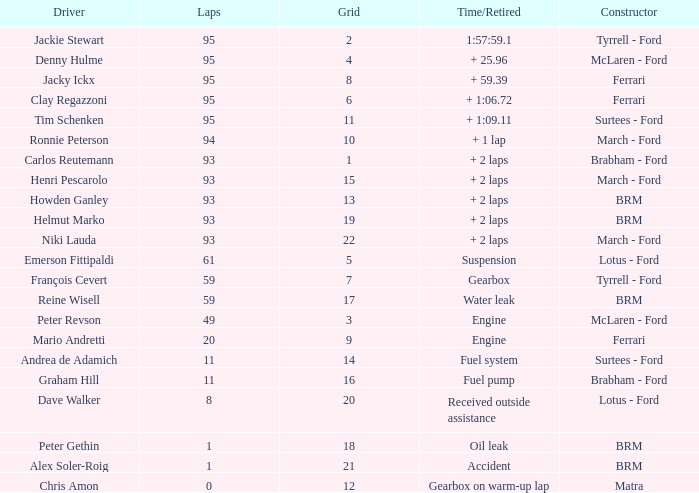What is the total number of grids for peter gethin? 18.0. 